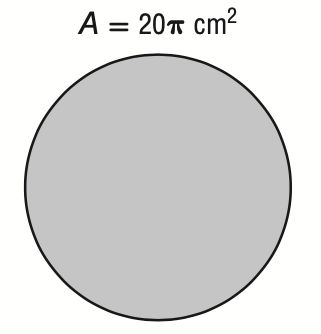Answer the mathemtical geometry problem and directly provide the correct option letter.
Question: The area of a circle is 20 \pi square centimeters. What is its circumference?
Choices: A: \sqrt 5 \pi B: 2 \sqrt 5 \pi C: 4 \sqrt 5 \pi D: 20 \pi C 